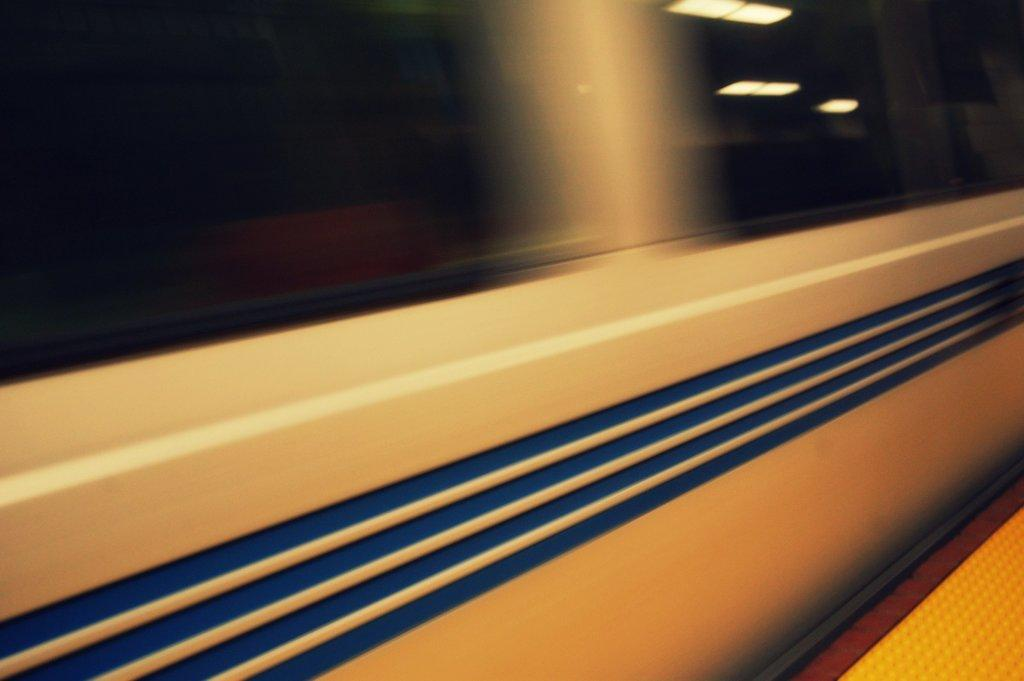What is the main subject of the image? The main subject of the image is a train. Can you describe the train's location in the image? The train is on a track in the image. How many worms can be seen crawling on the train in the image? There are no worms present in the image; it features a train on a track. 